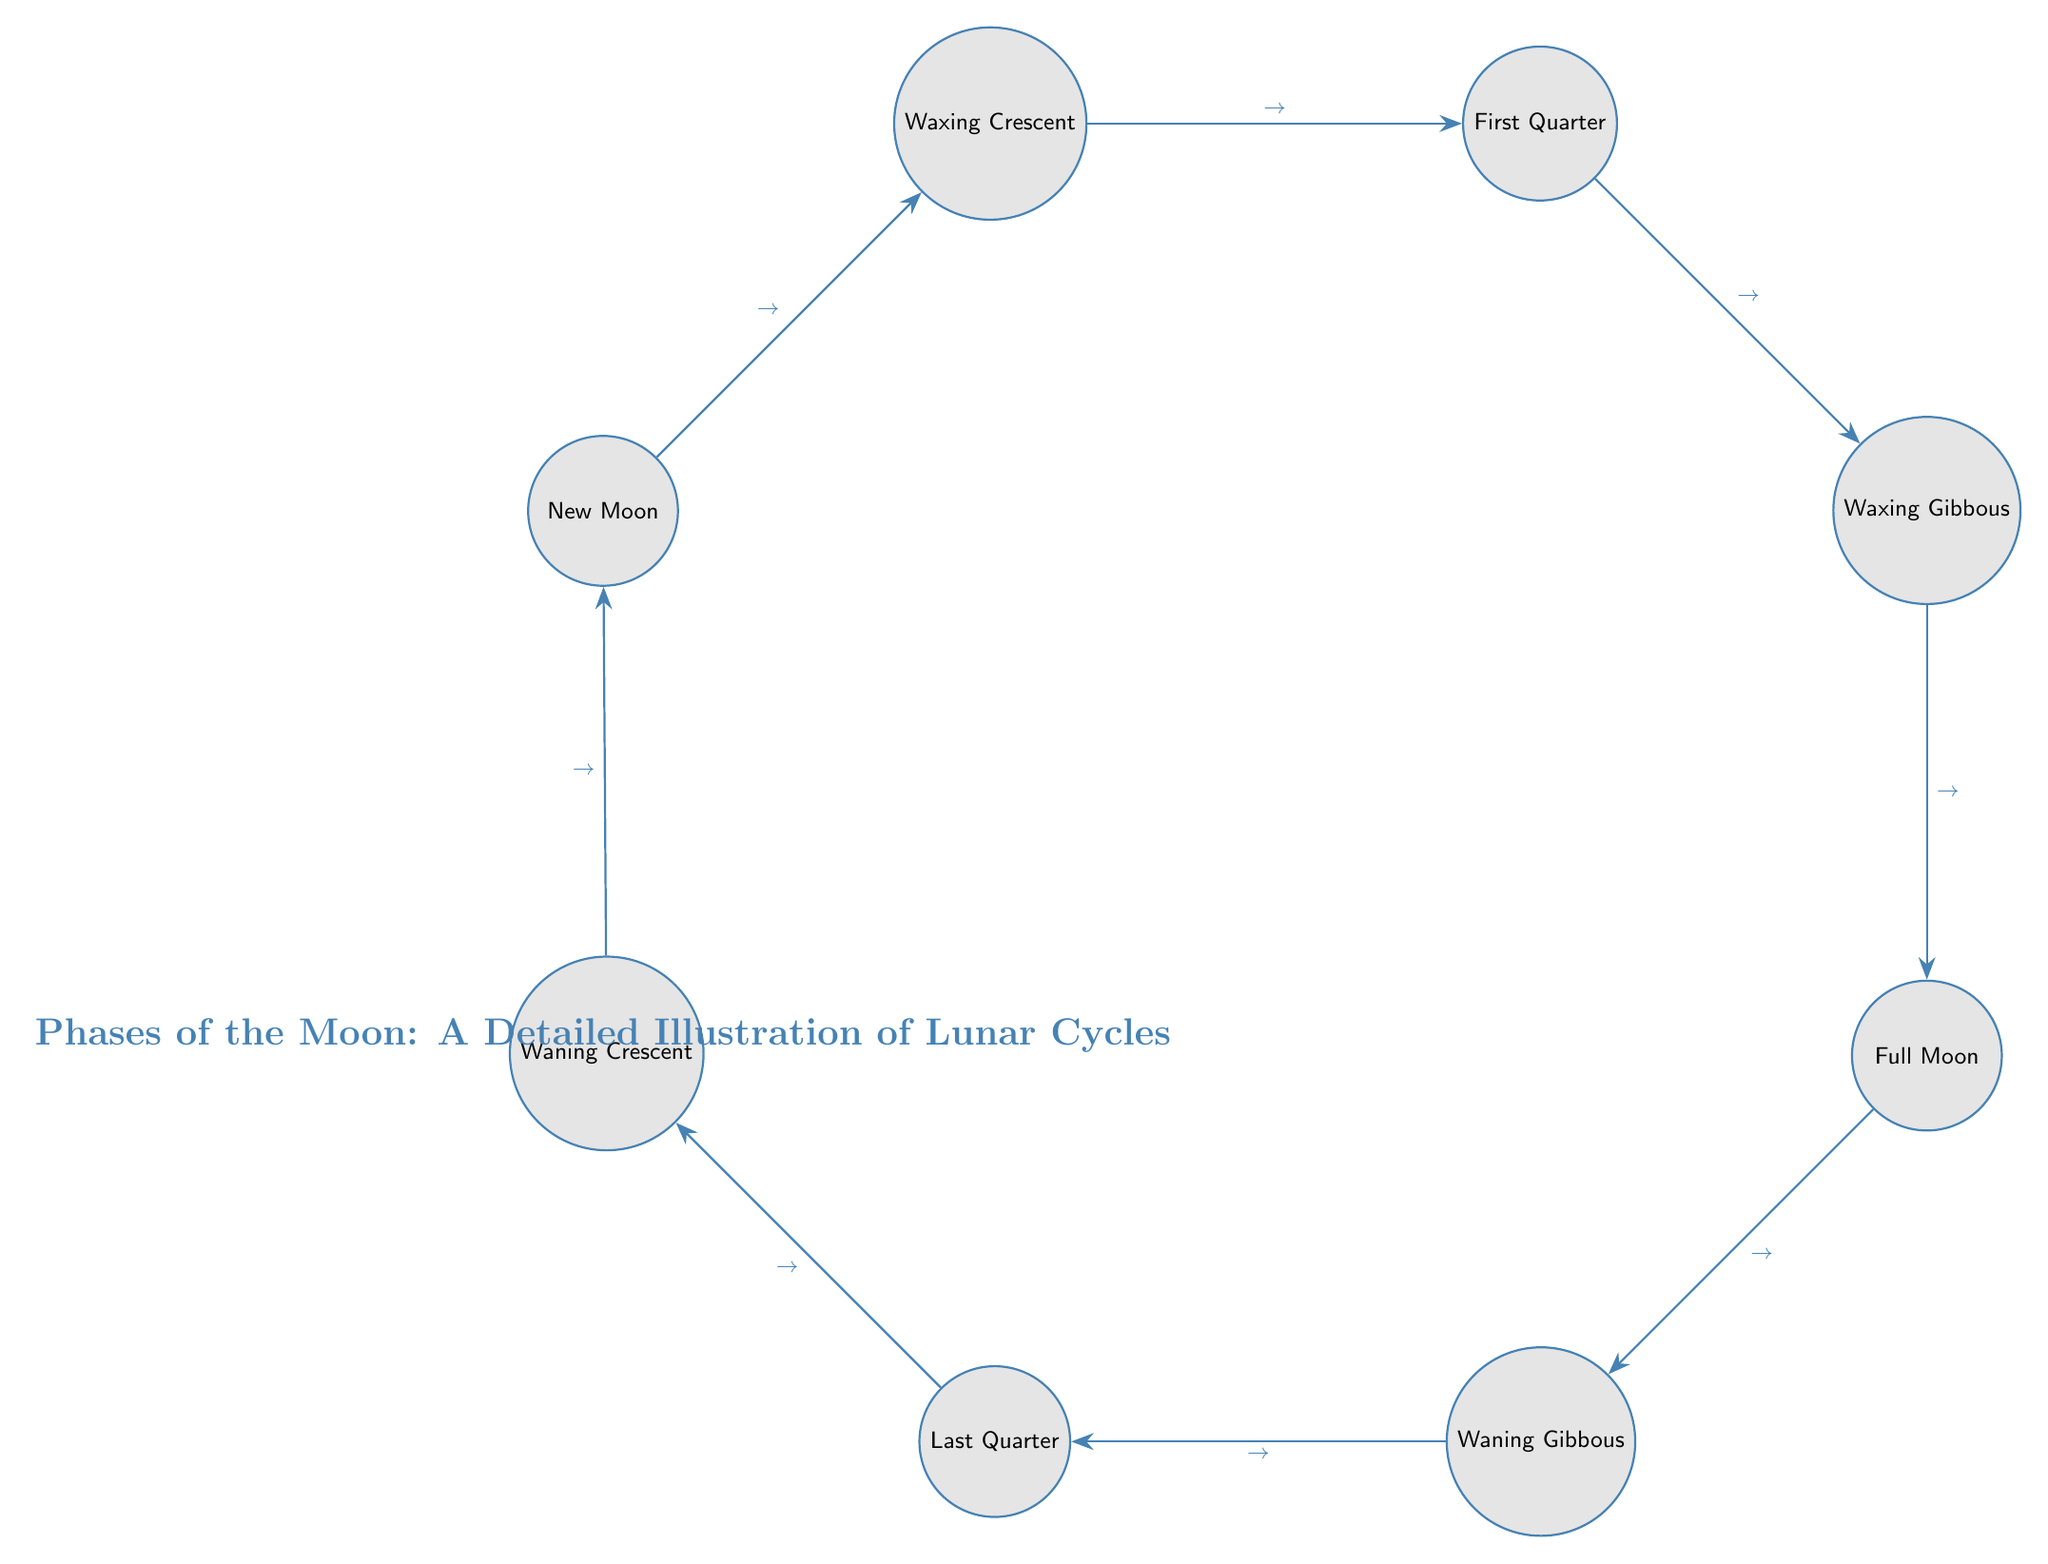What is the first phase of the Moon shown in the diagram? The diagram starts with "New Moon" at the top left, which indicates that it is the first phase in the lunar cycle.
Answer: New Moon How many phases of the Moon are depicted in the diagram? The diagram includes eight distinct phases of the Moon, which are visually represented as nodes: New Moon, Waxing Crescent, First Quarter, Waxing Gibbous, Full Moon, Waning Gibbous, Last Quarter, and Waning Crescent.
Answer: 8 What phase comes after the First Quarter in the diagram? Following the arrow from "First Quarter," the next phase shown is "Waxing Gibbous," indicating this is the sequential lunar phase.
Answer: Waxing Gibbous Which phase is directly opposite the New Moon in the diagram? The "Full Moon" phase is directly opposite the "New Moon" phase in the circular layout of the diagram, representing the opposite point in the lunar cycle.
Answer: Full Moon What type of transition occurs between the Waning Gibbous and Last Quarter phases? The diagram indicates a sequential transition from "Waning Gibbous" to "Last Quarter" through an arrow pointing from the former to the latter, showcasing the progression of lunar phases.
Answer: Transition What is the phase before the New Moon according to the diagram's cycle? The cycle illustrated loops back to "Waning Crescent" before reaching "New Moon," indicating its position directly before the new cycle begins.
Answer: Waning Crescent Which two phases are adjacent to the Waxing Gibbous in the diagram? "First Quarter" is to the left of "Waxing Gibbous," and "Full Moon" is below it, showing the direct connections between these three phases in the lunar progression.
Answer: First Quarter, Full Moon How do the phases progress from Full Moon to Waning Gibbous in the cycle? After reaching "Full Moon," the diagram indicates a flow to "Waning Gibbous," indicating that as the Moon wanes, it transitions from its full illumination to a gibbous form decreasing in size.
Answer: Transition to Waning Gibbous 